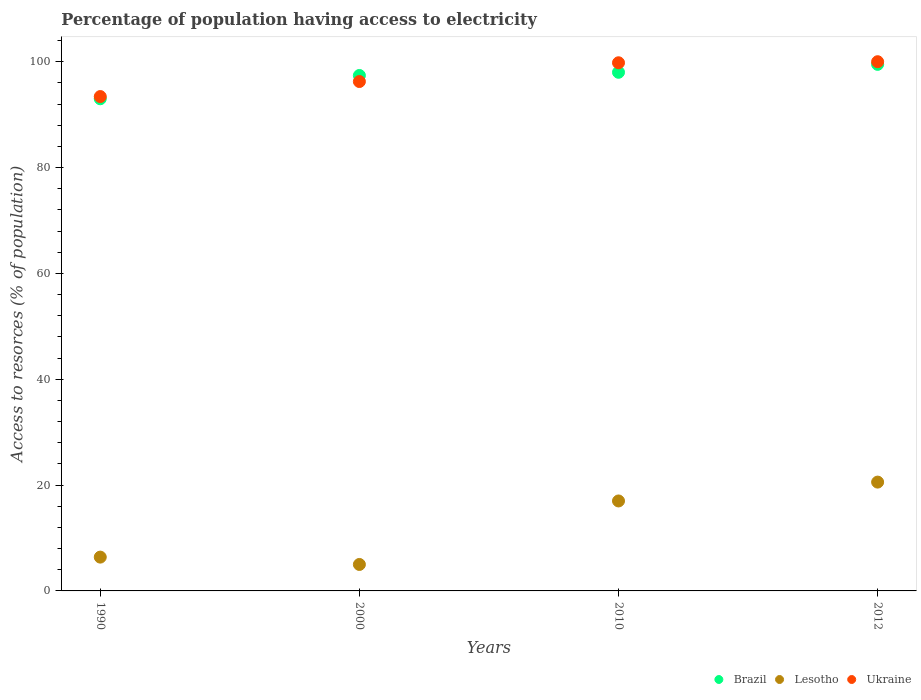How many different coloured dotlines are there?
Offer a terse response. 3. Is the number of dotlines equal to the number of legend labels?
Your answer should be compact. Yes. Across all years, what is the minimum percentage of population having access to electricity in Lesotho?
Your answer should be very brief. 5. In which year was the percentage of population having access to electricity in Ukraine maximum?
Your answer should be compact. 2012. In which year was the percentage of population having access to electricity in Lesotho minimum?
Keep it short and to the point. 2000. What is the total percentage of population having access to electricity in Lesotho in the graph?
Make the answer very short. 48.95. What is the difference between the percentage of population having access to electricity in Ukraine in 1990 and that in 2000?
Ensure brevity in your answer.  -2.84. What is the difference between the percentage of population having access to electricity in Ukraine in 2000 and the percentage of population having access to electricity in Brazil in 2010?
Provide a succinct answer. -1.74. What is the average percentage of population having access to electricity in Brazil per year?
Give a very brief answer. 96.97. In the year 2000, what is the difference between the percentage of population having access to electricity in Lesotho and percentage of population having access to electricity in Brazil?
Make the answer very short. -92.4. What is the ratio of the percentage of population having access to electricity in Ukraine in 2000 to that in 2012?
Offer a very short reply. 0.96. Is the percentage of population having access to electricity in Lesotho in 2010 less than that in 2012?
Provide a short and direct response. Yes. What is the difference between the highest and the lowest percentage of population having access to electricity in Ukraine?
Give a very brief answer. 6.58. In how many years, is the percentage of population having access to electricity in Brazil greater than the average percentage of population having access to electricity in Brazil taken over all years?
Make the answer very short. 3. How many years are there in the graph?
Ensure brevity in your answer.  4. Does the graph contain any zero values?
Provide a short and direct response. No. What is the title of the graph?
Your response must be concise. Percentage of population having access to electricity. Does "Mongolia" appear as one of the legend labels in the graph?
Provide a succinct answer. No. What is the label or title of the X-axis?
Your answer should be very brief. Years. What is the label or title of the Y-axis?
Give a very brief answer. Access to resorces (% of population). What is the Access to resorces (% of population) of Brazil in 1990?
Ensure brevity in your answer.  93. What is the Access to resorces (% of population) of Lesotho in 1990?
Your response must be concise. 6.39. What is the Access to resorces (% of population) in Ukraine in 1990?
Keep it short and to the point. 93.42. What is the Access to resorces (% of population) in Brazil in 2000?
Provide a succinct answer. 97.4. What is the Access to resorces (% of population) of Lesotho in 2000?
Offer a very short reply. 5. What is the Access to resorces (% of population) of Ukraine in 2000?
Keep it short and to the point. 96.26. What is the Access to resorces (% of population) in Brazil in 2010?
Ensure brevity in your answer.  98. What is the Access to resorces (% of population) of Ukraine in 2010?
Give a very brief answer. 99.8. What is the Access to resorces (% of population) of Brazil in 2012?
Offer a terse response. 99.5. What is the Access to resorces (% of population) in Lesotho in 2012?
Your response must be concise. 20.56. Across all years, what is the maximum Access to resorces (% of population) of Brazil?
Your answer should be compact. 99.5. Across all years, what is the maximum Access to resorces (% of population) of Lesotho?
Give a very brief answer. 20.56. Across all years, what is the maximum Access to resorces (% of population) in Ukraine?
Keep it short and to the point. 100. Across all years, what is the minimum Access to resorces (% of population) of Brazil?
Your answer should be compact. 93. Across all years, what is the minimum Access to resorces (% of population) of Lesotho?
Your answer should be very brief. 5. Across all years, what is the minimum Access to resorces (% of population) in Ukraine?
Offer a terse response. 93.42. What is the total Access to resorces (% of population) in Brazil in the graph?
Keep it short and to the point. 387.9. What is the total Access to resorces (% of population) in Lesotho in the graph?
Your response must be concise. 48.95. What is the total Access to resorces (% of population) in Ukraine in the graph?
Offer a very short reply. 389.47. What is the difference between the Access to resorces (% of population) of Lesotho in 1990 and that in 2000?
Ensure brevity in your answer.  1.39. What is the difference between the Access to resorces (% of population) in Ukraine in 1990 and that in 2000?
Offer a very short reply. -2.84. What is the difference between the Access to resorces (% of population) of Lesotho in 1990 and that in 2010?
Give a very brief answer. -10.61. What is the difference between the Access to resorces (% of population) in Ukraine in 1990 and that in 2010?
Your answer should be compact. -6.38. What is the difference between the Access to resorces (% of population) of Brazil in 1990 and that in 2012?
Provide a succinct answer. -6.5. What is the difference between the Access to resorces (% of population) of Lesotho in 1990 and that in 2012?
Ensure brevity in your answer.  -14.17. What is the difference between the Access to resorces (% of population) of Ukraine in 1990 and that in 2012?
Provide a succinct answer. -6.58. What is the difference between the Access to resorces (% of population) of Ukraine in 2000 and that in 2010?
Ensure brevity in your answer.  -3.54. What is the difference between the Access to resorces (% of population) in Brazil in 2000 and that in 2012?
Your response must be concise. -2.1. What is the difference between the Access to resorces (% of population) of Lesotho in 2000 and that in 2012?
Give a very brief answer. -15.56. What is the difference between the Access to resorces (% of population) in Ukraine in 2000 and that in 2012?
Offer a terse response. -3.74. What is the difference between the Access to resorces (% of population) in Lesotho in 2010 and that in 2012?
Make the answer very short. -3.56. What is the difference between the Access to resorces (% of population) in Ukraine in 2010 and that in 2012?
Offer a terse response. -0.2. What is the difference between the Access to resorces (% of population) in Brazil in 1990 and the Access to resorces (% of population) in Ukraine in 2000?
Your response must be concise. -3.26. What is the difference between the Access to resorces (% of population) of Lesotho in 1990 and the Access to resorces (% of population) of Ukraine in 2000?
Ensure brevity in your answer.  -89.87. What is the difference between the Access to resorces (% of population) in Brazil in 1990 and the Access to resorces (% of population) in Lesotho in 2010?
Your response must be concise. 76. What is the difference between the Access to resorces (% of population) in Lesotho in 1990 and the Access to resorces (% of population) in Ukraine in 2010?
Ensure brevity in your answer.  -93.41. What is the difference between the Access to resorces (% of population) of Brazil in 1990 and the Access to resorces (% of population) of Lesotho in 2012?
Provide a short and direct response. 72.44. What is the difference between the Access to resorces (% of population) in Lesotho in 1990 and the Access to resorces (% of population) in Ukraine in 2012?
Your answer should be compact. -93.61. What is the difference between the Access to resorces (% of population) of Brazil in 2000 and the Access to resorces (% of population) of Lesotho in 2010?
Provide a short and direct response. 80.4. What is the difference between the Access to resorces (% of population) in Brazil in 2000 and the Access to resorces (% of population) in Ukraine in 2010?
Your response must be concise. -2.4. What is the difference between the Access to resorces (% of population) in Lesotho in 2000 and the Access to resorces (% of population) in Ukraine in 2010?
Offer a terse response. -94.8. What is the difference between the Access to resorces (% of population) of Brazil in 2000 and the Access to resorces (% of population) of Lesotho in 2012?
Your response must be concise. 76.84. What is the difference between the Access to resorces (% of population) in Brazil in 2000 and the Access to resorces (% of population) in Ukraine in 2012?
Your answer should be very brief. -2.6. What is the difference between the Access to resorces (% of population) of Lesotho in 2000 and the Access to resorces (% of population) of Ukraine in 2012?
Provide a succinct answer. -95. What is the difference between the Access to resorces (% of population) in Brazil in 2010 and the Access to resorces (% of population) in Lesotho in 2012?
Your answer should be compact. 77.44. What is the difference between the Access to resorces (% of population) of Lesotho in 2010 and the Access to resorces (% of population) of Ukraine in 2012?
Provide a succinct answer. -83. What is the average Access to resorces (% of population) in Brazil per year?
Your answer should be compact. 96.97. What is the average Access to resorces (% of population) of Lesotho per year?
Offer a terse response. 12.24. What is the average Access to resorces (% of population) in Ukraine per year?
Give a very brief answer. 97.37. In the year 1990, what is the difference between the Access to resorces (% of population) of Brazil and Access to resorces (% of population) of Lesotho?
Offer a terse response. 86.61. In the year 1990, what is the difference between the Access to resorces (% of population) of Brazil and Access to resorces (% of population) of Ukraine?
Your answer should be very brief. -0.42. In the year 1990, what is the difference between the Access to resorces (% of population) of Lesotho and Access to resorces (% of population) of Ukraine?
Offer a terse response. -87.03. In the year 2000, what is the difference between the Access to resorces (% of population) of Brazil and Access to resorces (% of population) of Lesotho?
Provide a succinct answer. 92.4. In the year 2000, what is the difference between the Access to resorces (% of population) in Brazil and Access to resorces (% of population) in Ukraine?
Provide a succinct answer. 1.14. In the year 2000, what is the difference between the Access to resorces (% of population) of Lesotho and Access to resorces (% of population) of Ukraine?
Keep it short and to the point. -91.26. In the year 2010, what is the difference between the Access to resorces (% of population) of Brazil and Access to resorces (% of population) of Ukraine?
Offer a terse response. -1.8. In the year 2010, what is the difference between the Access to resorces (% of population) in Lesotho and Access to resorces (% of population) in Ukraine?
Make the answer very short. -82.8. In the year 2012, what is the difference between the Access to resorces (% of population) in Brazil and Access to resorces (% of population) in Lesotho?
Your answer should be very brief. 78.94. In the year 2012, what is the difference between the Access to resorces (% of population) in Lesotho and Access to resorces (% of population) in Ukraine?
Make the answer very short. -79.44. What is the ratio of the Access to resorces (% of population) of Brazil in 1990 to that in 2000?
Provide a succinct answer. 0.95. What is the ratio of the Access to resorces (% of population) in Lesotho in 1990 to that in 2000?
Your answer should be very brief. 1.28. What is the ratio of the Access to resorces (% of population) of Ukraine in 1990 to that in 2000?
Your response must be concise. 0.97. What is the ratio of the Access to resorces (% of population) in Brazil in 1990 to that in 2010?
Provide a short and direct response. 0.95. What is the ratio of the Access to resorces (% of population) in Lesotho in 1990 to that in 2010?
Offer a terse response. 0.38. What is the ratio of the Access to resorces (% of population) of Ukraine in 1990 to that in 2010?
Give a very brief answer. 0.94. What is the ratio of the Access to resorces (% of population) of Brazil in 1990 to that in 2012?
Make the answer very short. 0.93. What is the ratio of the Access to resorces (% of population) of Lesotho in 1990 to that in 2012?
Provide a succinct answer. 0.31. What is the ratio of the Access to resorces (% of population) of Ukraine in 1990 to that in 2012?
Offer a very short reply. 0.93. What is the ratio of the Access to resorces (% of population) in Lesotho in 2000 to that in 2010?
Your answer should be very brief. 0.29. What is the ratio of the Access to resorces (% of population) of Ukraine in 2000 to that in 2010?
Ensure brevity in your answer.  0.96. What is the ratio of the Access to resorces (% of population) in Brazil in 2000 to that in 2012?
Your response must be concise. 0.98. What is the ratio of the Access to resorces (% of population) in Lesotho in 2000 to that in 2012?
Provide a short and direct response. 0.24. What is the ratio of the Access to resorces (% of population) of Ukraine in 2000 to that in 2012?
Make the answer very short. 0.96. What is the ratio of the Access to resorces (% of population) of Brazil in 2010 to that in 2012?
Your answer should be compact. 0.98. What is the ratio of the Access to resorces (% of population) of Lesotho in 2010 to that in 2012?
Your response must be concise. 0.83. What is the difference between the highest and the second highest Access to resorces (% of population) of Brazil?
Your answer should be compact. 1.5. What is the difference between the highest and the second highest Access to resorces (% of population) of Lesotho?
Make the answer very short. 3.56. What is the difference between the highest and the second highest Access to resorces (% of population) of Ukraine?
Keep it short and to the point. 0.2. What is the difference between the highest and the lowest Access to resorces (% of population) in Brazil?
Make the answer very short. 6.5. What is the difference between the highest and the lowest Access to resorces (% of population) in Lesotho?
Your answer should be compact. 15.56. What is the difference between the highest and the lowest Access to resorces (% of population) of Ukraine?
Your answer should be very brief. 6.58. 